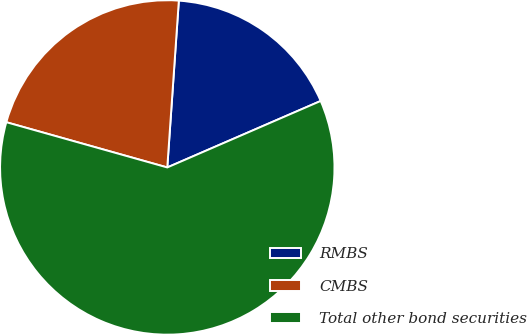<chart> <loc_0><loc_0><loc_500><loc_500><pie_chart><fcel>RMBS<fcel>CMBS<fcel>Total other bond securities<nl><fcel>17.39%<fcel>21.74%<fcel>60.87%<nl></chart> 